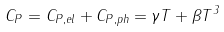<formula> <loc_0><loc_0><loc_500><loc_500>C _ { P } = C _ { P , { e l } } + C _ { P , { p h } } = \gamma T + \beta T ^ { 3 }</formula> 